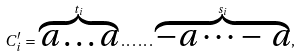Convert formula to latex. <formula><loc_0><loc_0><loc_500><loc_500>C ^ { \prime } _ { i } = \overbrace { a \dots a } ^ { t _ { i } } \dots \dots \overbrace { - a \dots - \, a } ^ { s _ { i } } ,</formula> 